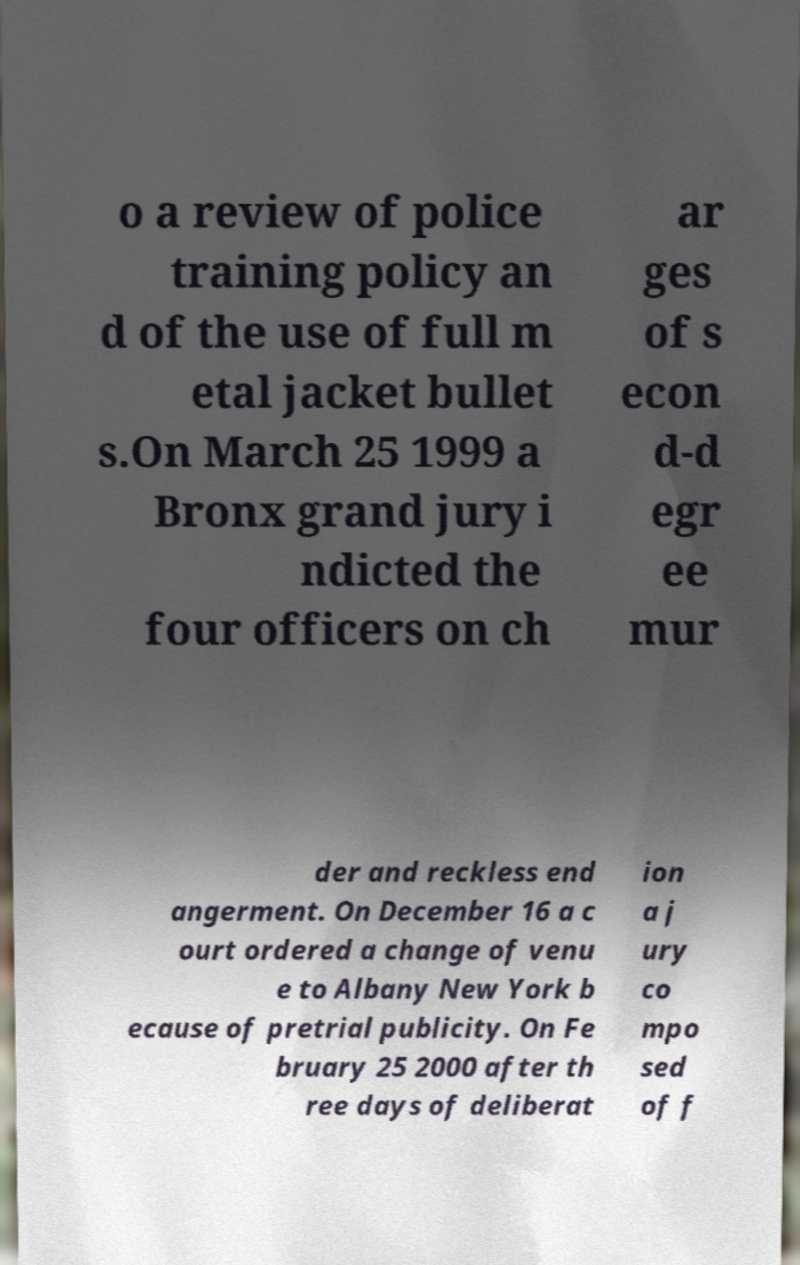Can you read and provide the text displayed in the image?This photo seems to have some interesting text. Can you extract and type it out for me? o a review of police training policy an d of the use of full m etal jacket bullet s.On March 25 1999 a Bronx grand jury i ndicted the four officers on ch ar ges of s econ d-d egr ee mur der and reckless end angerment. On December 16 a c ourt ordered a change of venu e to Albany New York b ecause of pretrial publicity. On Fe bruary 25 2000 after th ree days of deliberat ion a j ury co mpo sed of f 